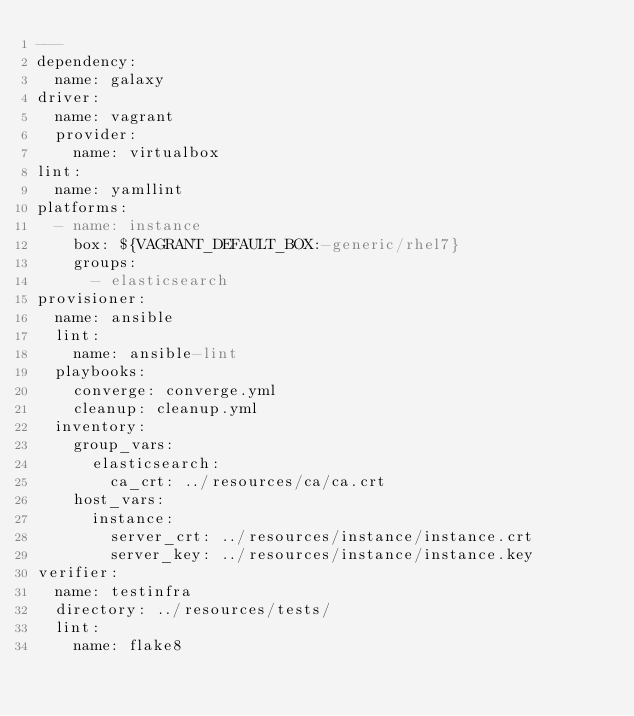<code> <loc_0><loc_0><loc_500><loc_500><_YAML_>---
dependency:
  name: galaxy
driver:
  name: vagrant
  provider:
    name: virtualbox
lint:
  name: yamllint
platforms:
  - name: instance
    box: ${VAGRANT_DEFAULT_BOX:-generic/rhel7}
    groups:
      - elasticsearch
provisioner:
  name: ansible
  lint:
    name: ansible-lint
  playbooks:
    converge: converge.yml
    cleanup: cleanup.yml
  inventory:
    group_vars:
      elasticsearch:
        ca_crt: ../resources/ca/ca.crt
    host_vars:
      instance:
        server_crt: ../resources/instance/instance.crt
        server_key: ../resources/instance/instance.key
verifier:
  name: testinfra
  directory: ../resources/tests/
  lint:
    name: flake8
</code> 